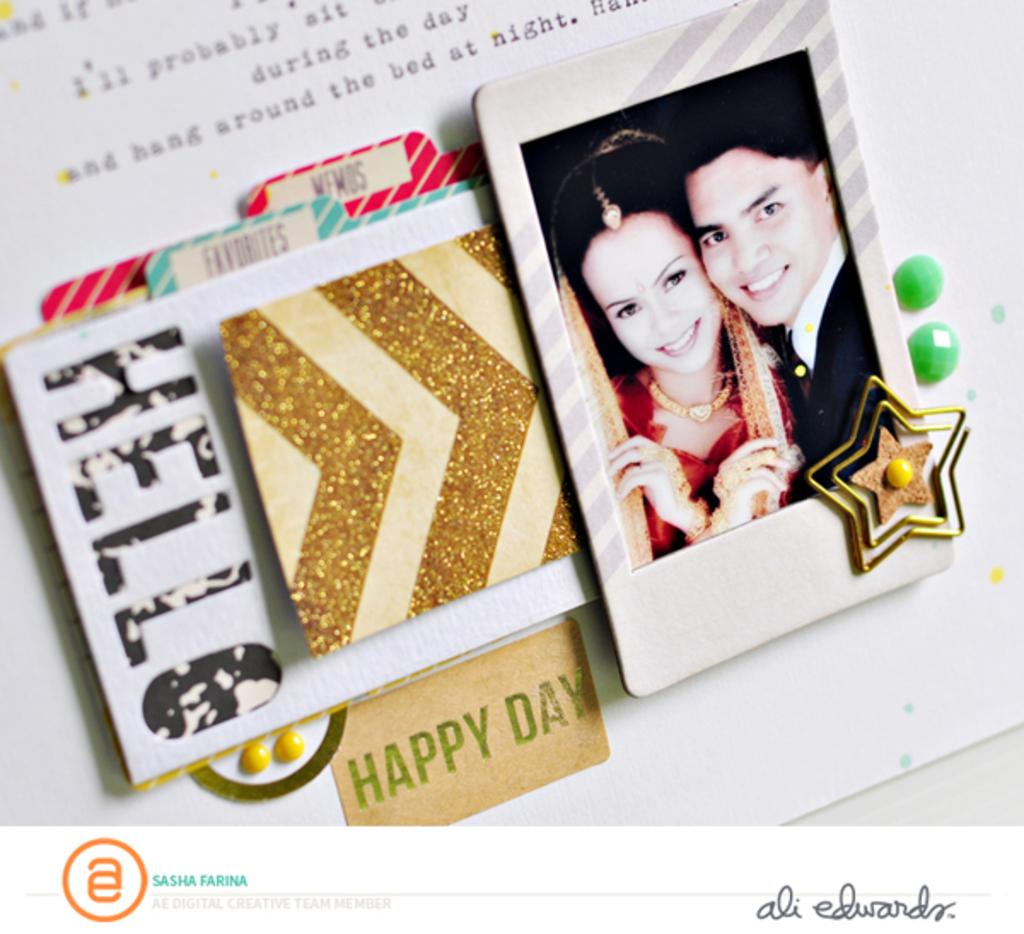What is the main object in the image? There is a greeting card in the image. What can be seen at the top of the image? There is text at the top of the image. What type of image is present on the greeting card? There is a picture of a man and a woman in the image. Where is the logo located on the greeting card? The logo is at the left bottom of the image. How many bells are hanging from the man's neck in the image? There are no bells present in the image; the picture on the greeting card features a man and a woman without any bells. 